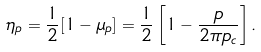<formula> <loc_0><loc_0><loc_500><loc_500>\eta _ { p } = \frac { 1 } { 2 } [ 1 - \mu _ { p } ] = \frac { 1 } { 2 } \left [ 1 - \frac { p } { 2 \pi p _ { c } } \right ] .</formula> 